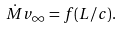<formula> <loc_0><loc_0><loc_500><loc_500>\dot { M } v _ { \infty } = f ( L / c ) .</formula> 